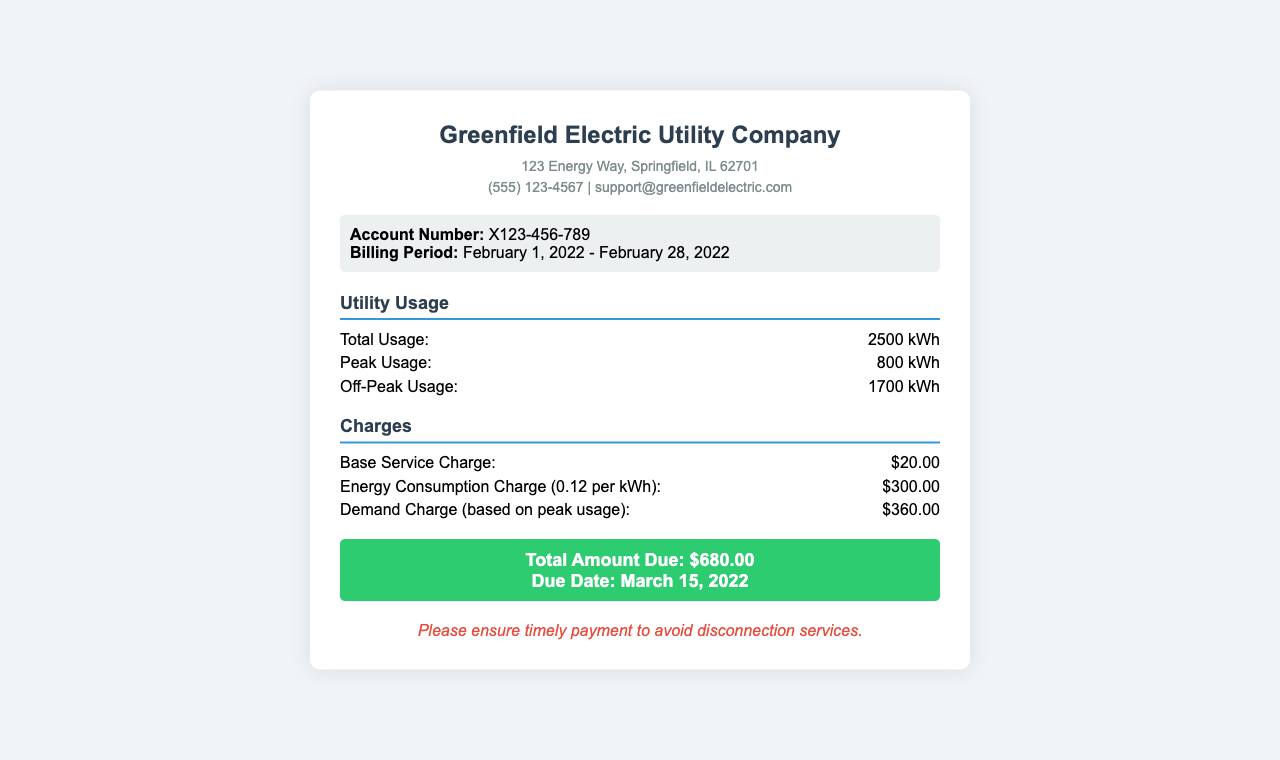What is the account number? The account number is specified in the account information section of the document.
Answer: X123-456-789 What is the total usage of electricity for February 2022? The total usage is indicated in the utility usage section as the sum for the billing period.
Answer: 2500 kWh What is the due date for the payment? The due date is mentioned in the total amount due section of the document.
Answer: March 15, 2022 What is the base service charge? The base service charge is listed under the charges section of the receipt.
Answer: $20.00 How much was the demand charge? The demand charge is provided in the breakdown of charges related to peak usage.
Answer: $360.00 How much energy was consumed during off-peak hours? The off-peak usage figure is shown in the utility usage section of the document.
Answer: 1700 kWh What is the total amount due? The total amount due is specified in the billing summary of the receipt.
Answer: $680.00 What is the energy consumption charge per kWh? The energy consumption charge is indicated in the charges section as a rate per kWh.
Answer: 0.12 per kWh What company issued this utility bill receipt? The company name is prominently displayed at the top of the receipt document.
Answer: Greenfield Electric Utility Company 